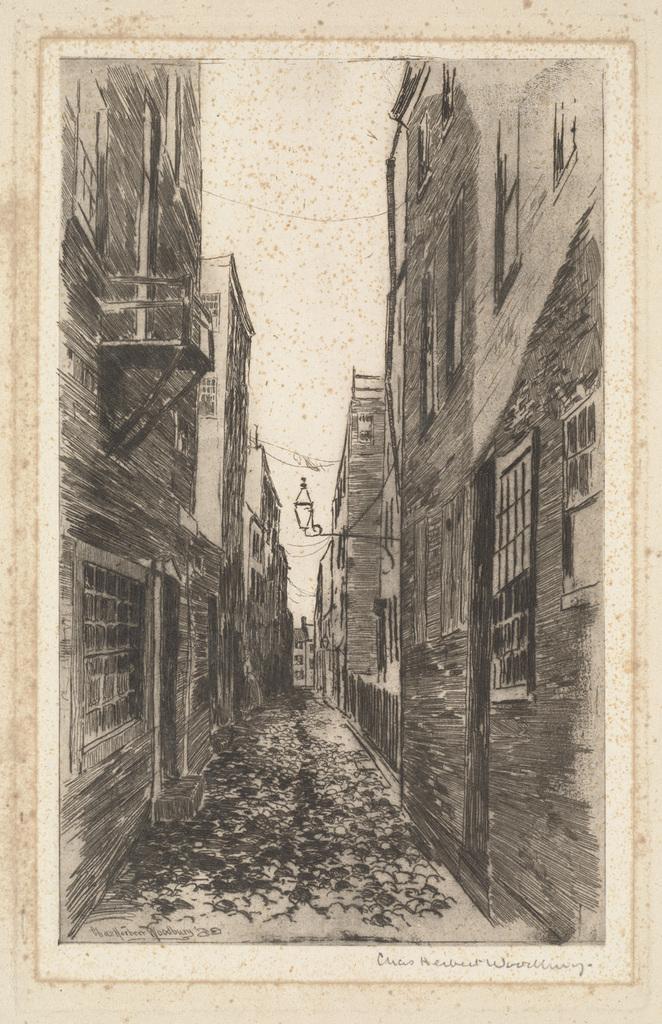Could you give a brief overview of what you see in this image? This is an edited image. In the center we can see there are some objects on the ground and on both the sides we can see the buildings and we can see a lamp. In the background we can see the sky. In the bottom right corner we can see the text on the image. 